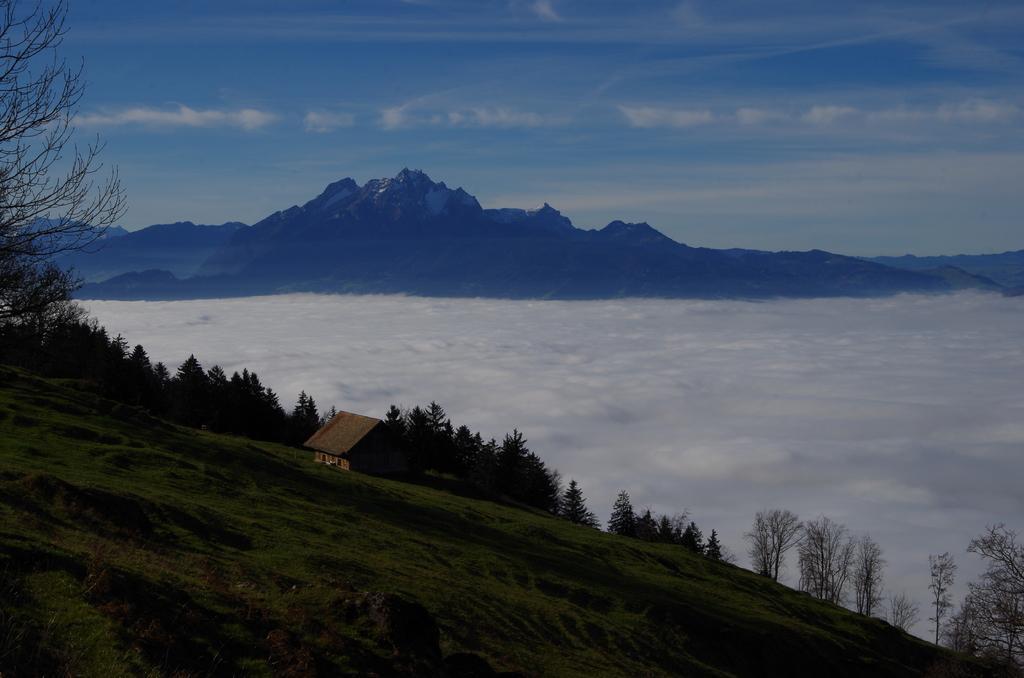In one or two sentences, can you explain what this image depicts? In this image there is slope land, on that land there is a house and trees, in the background there is snow, mountains and the sky. 